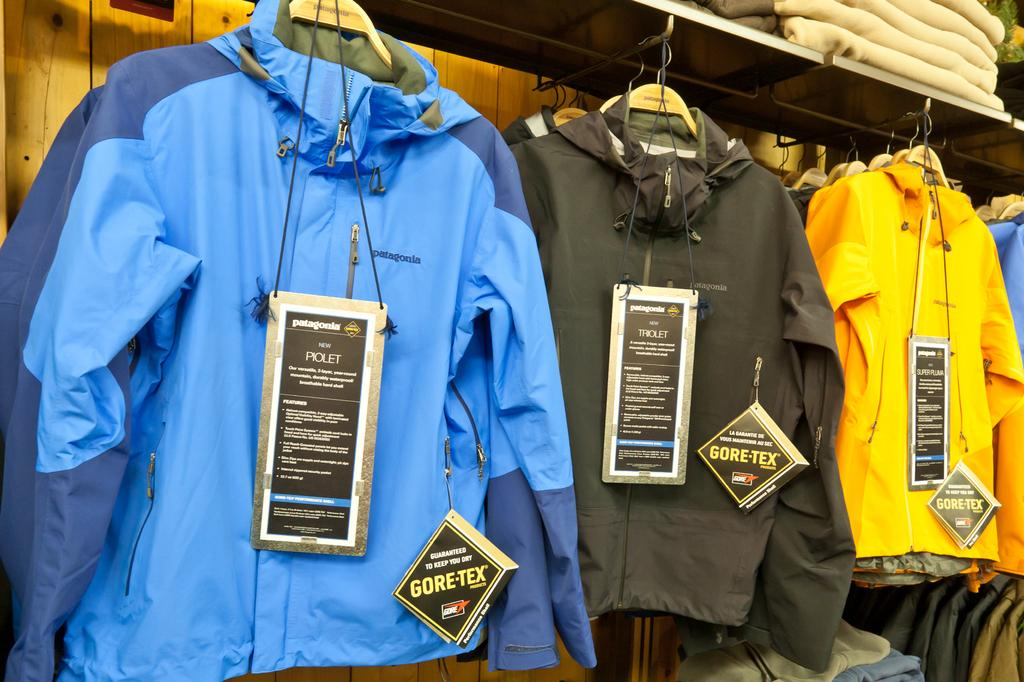What type of clothing can be seen in the image? There are jackets in the image. What else is hanging in the image besides the jackets? There are tags hanged in the image. Where are the towels located in the image? Towels are arranged in a shelf in the right top of the image. What is the background of the image made of? There is a wooden wall in the background of the image. What type of dime can be seen in the mouth of the person in the image? There is no person or dime present in the image. 